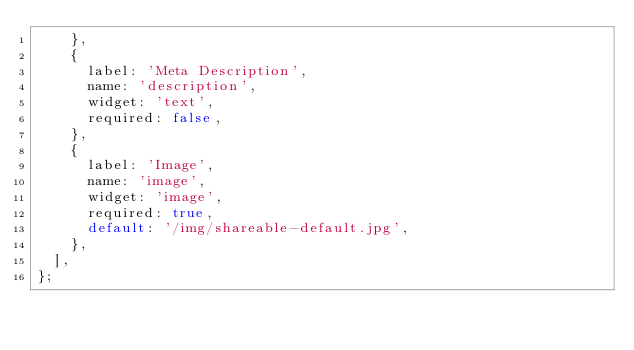<code> <loc_0><loc_0><loc_500><loc_500><_JavaScript_>		},
		{
			label: 'Meta Description',
			name: 'description',
			widget: 'text',
			required: false,
		},
		{
			label: 'Image',
			name: 'image',
			widget: 'image',
			required: true,
			default: '/img/shareable-default.jpg',
		},
	],
};
</code> 